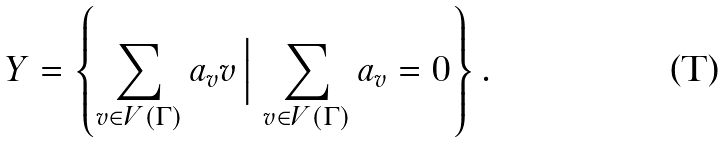Convert formula to latex. <formula><loc_0><loc_0><loc_500><loc_500>Y = \left \{ \sum _ { v \in V ( \Gamma ) } a _ { v } v \, \Big | \, \sum _ { v \in V ( \Gamma ) } a _ { v } = 0 \right \} .</formula> 